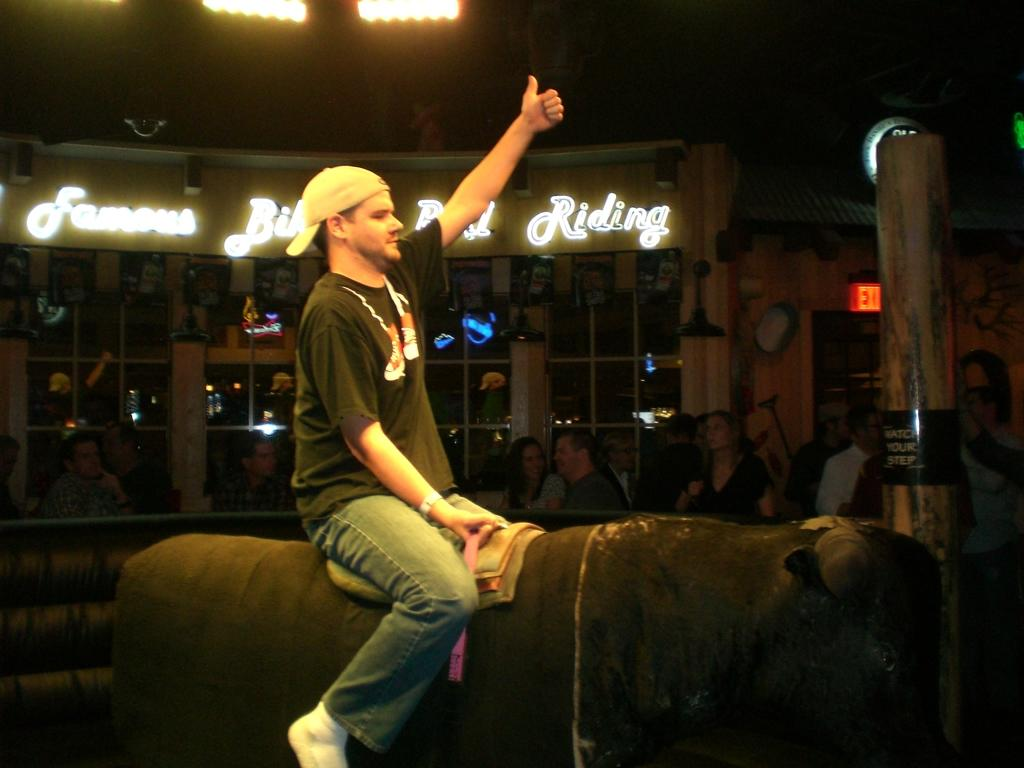What is the person in the image doing? The person is playing a rodeo bull game. Can you describe the person's attire? The person is wearing a cap. What can be seen in the background of the image? There are people, a pillar, boards, lights, and glasses in the background of the image. Is there an umbrella being used by the person playing the rodeo bull game in the image? No, there is no umbrella present in the image. Can you tell me what type of fruit is being served at the airport in the image? There is no airport or fruit present in the image; it features a person playing a rodeo bull game with various background elements. 